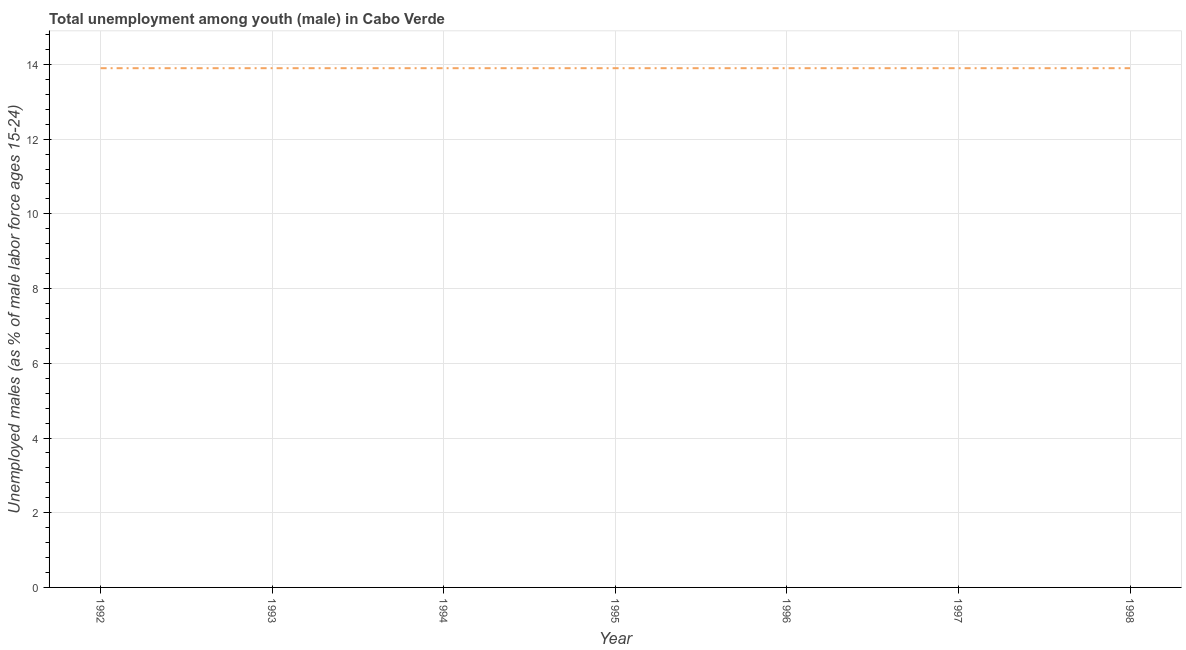What is the unemployed male youth population in 1994?
Your answer should be very brief. 13.9. Across all years, what is the maximum unemployed male youth population?
Give a very brief answer. 13.9. Across all years, what is the minimum unemployed male youth population?
Your response must be concise. 13.9. In which year was the unemployed male youth population minimum?
Offer a very short reply. 1992. What is the sum of the unemployed male youth population?
Give a very brief answer. 97.3. What is the difference between the unemployed male youth population in 1994 and 1995?
Your answer should be compact. 0. What is the average unemployed male youth population per year?
Your response must be concise. 13.9. What is the median unemployed male youth population?
Your answer should be compact. 13.9. In how many years, is the unemployed male youth population greater than 2.8 %?
Give a very brief answer. 7. Do a majority of the years between 1995 and 1997 (inclusive) have unemployed male youth population greater than 14.4 %?
Ensure brevity in your answer.  No. What is the ratio of the unemployed male youth population in 1996 to that in 1997?
Make the answer very short. 1. Is the unemployed male youth population in 1995 less than that in 1998?
Make the answer very short. No. Is the difference between the unemployed male youth population in 1992 and 1998 greater than the difference between any two years?
Ensure brevity in your answer.  Yes. What is the difference between the highest and the second highest unemployed male youth population?
Make the answer very short. 0. How many years are there in the graph?
Offer a terse response. 7. Are the values on the major ticks of Y-axis written in scientific E-notation?
Offer a terse response. No. Does the graph contain any zero values?
Offer a very short reply. No. Does the graph contain grids?
Offer a very short reply. Yes. What is the title of the graph?
Ensure brevity in your answer.  Total unemployment among youth (male) in Cabo Verde. What is the label or title of the X-axis?
Your answer should be compact. Year. What is the label or title of the Y-axis?
Ensure brevity in your answer.  Unemployed males (as % of male labor force ages 15-24). What is the Unemployed males (as % of male labor force ages 15-24) of 1992?
Offer a terse response. 13.9. What is the Unemployed males (as % of male labor force ages 15-24) of 1993?
Your answer should be compact. 13.9. What is the Unemployed males (as % of male labor force ages 15-24) of 1994?
Offer a very short reply. 13.9. What is the Unemployed males (as % of male labor force ages 15-24) in 1995?
Provide a succinct answer. 13.9. What is the Unemployed males (as % of male labor force ages 15-24) of 1996?
Keep it short and to the point. 13.9. What is the Unemployed males (as % of male labor force ages 15-24) of 1997?
Give a very brief answer. 13.9. What is the Unemployed males (as % of male labor force ages 15-24) of 1998?
Make the answer very short. 13.9. What is the difference between the Unemployed males (as % of male labor force ages 15-24) in 1992 and 1995?
Your answer should be very brief. 0. What is the difference between the Unemployed males (as % of male labor force ages 15-24) in 1992 and 1996?
Your answer should be very brief. 0. What is the difference between the Unemployed males (as % of male labor force ages 15-24) in 1992 and 1997?
Make the answer very short. 0. What is the difference between the Unemployed males (as % of male labor force ages 15-24) in 1992 and 1998?
Keep it short and to the point. 0. What is the difference between the Unemployed males (as % of male labor force ages 15-24) in 1993 and 1994?
Provide a succinct answer. 0. What is the difference between the Unemployed males (as % of male labor force ages 15-24) in 1994 and 1996?
Ensure brevity in your answer.  0. What is the difference between the Unemployed males (as % of male labor force ages 15-24) in 1994 and 1997?
Provide a short and direct response. 0. What is the difference between the Unemployed males (as % of male labor force ages 15-24) in 1995 and 1996?
Keep it short and to the point. 0. What is the difference between the Unemployed males (as % of male labor force ages 15-24) in 1996 and 1997?
Offer a very short reply. 0. What is the difference between the Unemployed males (as % of male labor force ages 15-24) in 1996 and 1998?
Give a very brief answer. 0. What is the ratio of the Unemployed males (as % of male labor force ages 15-24) in 1992 to that in 1994?
Make the answer very short. 1. What is the ratio of the Unemployed males (as % of male labor force ages 15-24) in 1992 to that in 1995?
Offer a terse response. 1. What is the ratio of the Unemployed males (as % of male labor force ages 15-24) in 1992 to that in 1996?
Your response must be concise. 1. What is the ratio of the Unemployed males (as % of male labor force ages 15-24) in 1992 to that in 1997?
Keep it short and to the point. 1. What is the ratio of the Unemployed males (as % of male labor force ages 15-24) in 1993 to that in 1996?
Provide a succinct answer. 1. What is the ratio of the Unemployed males (as % of male labor force ages 15-24) in 1993 to that in 1997?
Keep it short and to the point. 1. What is the ratio of the Unemployed males (as % of male labor force ages 15-24) in 1994 to that in 1997?
Make the answer very short. 1. What is the ratio of the Unemployed males (as % of male labor force ages 15-24) in 1994 to that in 1998?
Keep it short and to the point. 1. What is the ratio of the Unemployed males (as % of male labor force ages 15-24) in 1995 to that in 1996?
Provide a short and direct response. 1. What is the ratio of the Unemployed males (as % of male labor force ages 15-24) in 1995 to that in 1997?
Give a very brief answer. 1. What is the ratio of the Unemployed males (as % of male labor force ages 15-24) in 1996 to that in 1998?
Your answer should be compact. 1. What is the ratio of the Unemployed males (as % of male labor force ages 15-24) in 1997 to that in 1998?
Offer a terse response. 1. 